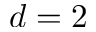Convert formula to latex. <formula><loc_0><loc_0><loc_500><loc_500>d = 2</formula> 